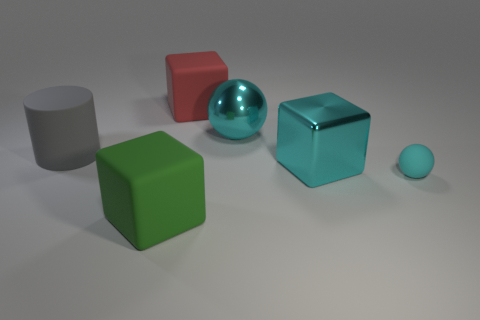Add 2 balls. How many objects exist? 8 Subtract all spheres. How many objects are left? 4 Add 2 cyan cubes. How many cyan cubes are left? 3 Add 4 cyan balls. How many cyan balls exist? 6 Subtract 0 brown cylinders. How many objects are left? 6 Subtract all small metal spheres. Subtract all big rubber cubes. How many objects are left? 4 